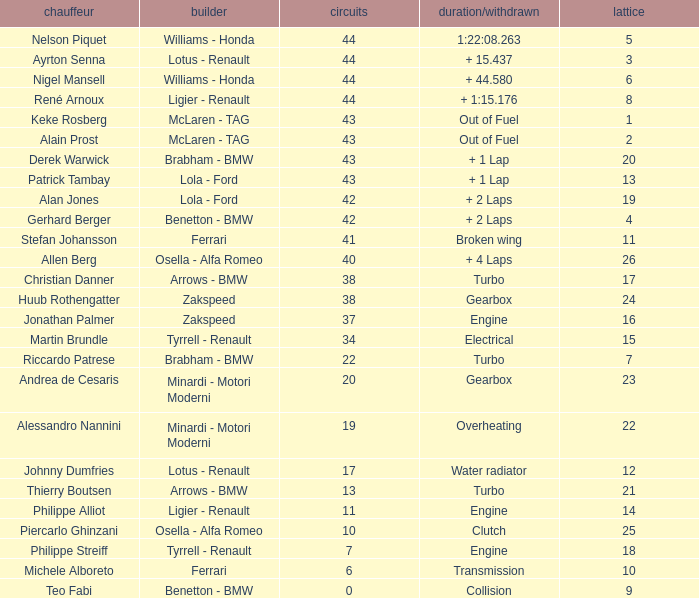Tell me the time/retired for Laps of 42 and Grids of 4 + 2 Laps. 